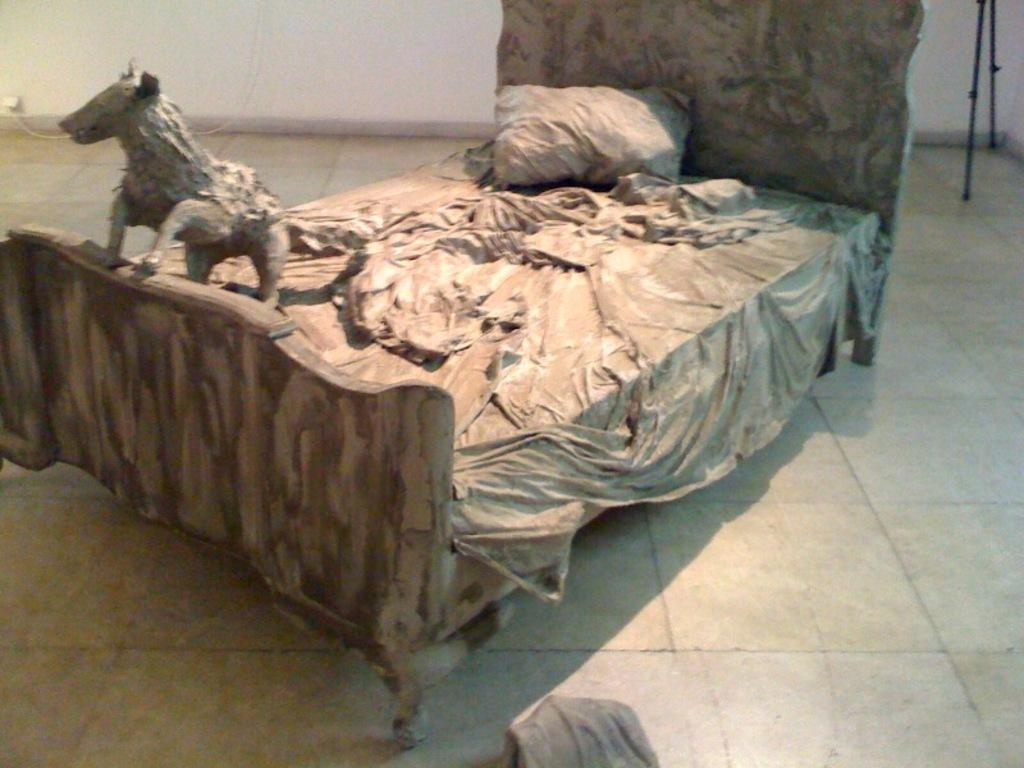What is the main object in the image? There is a cot in the image. What is covering the cot? There is a blanket on the cot. What is supporting the head on the cot? There is a pillow on the cot. What type of animal is on the cot? There is a dog on the cot. What can be seen in the background of the image? In the background of the image, there is a floor, a wall, and a stand. What type of chin can be seen on the dog in the image? There is no chin visible on the dog in the image; it is not a feature that can be seen in this context. 